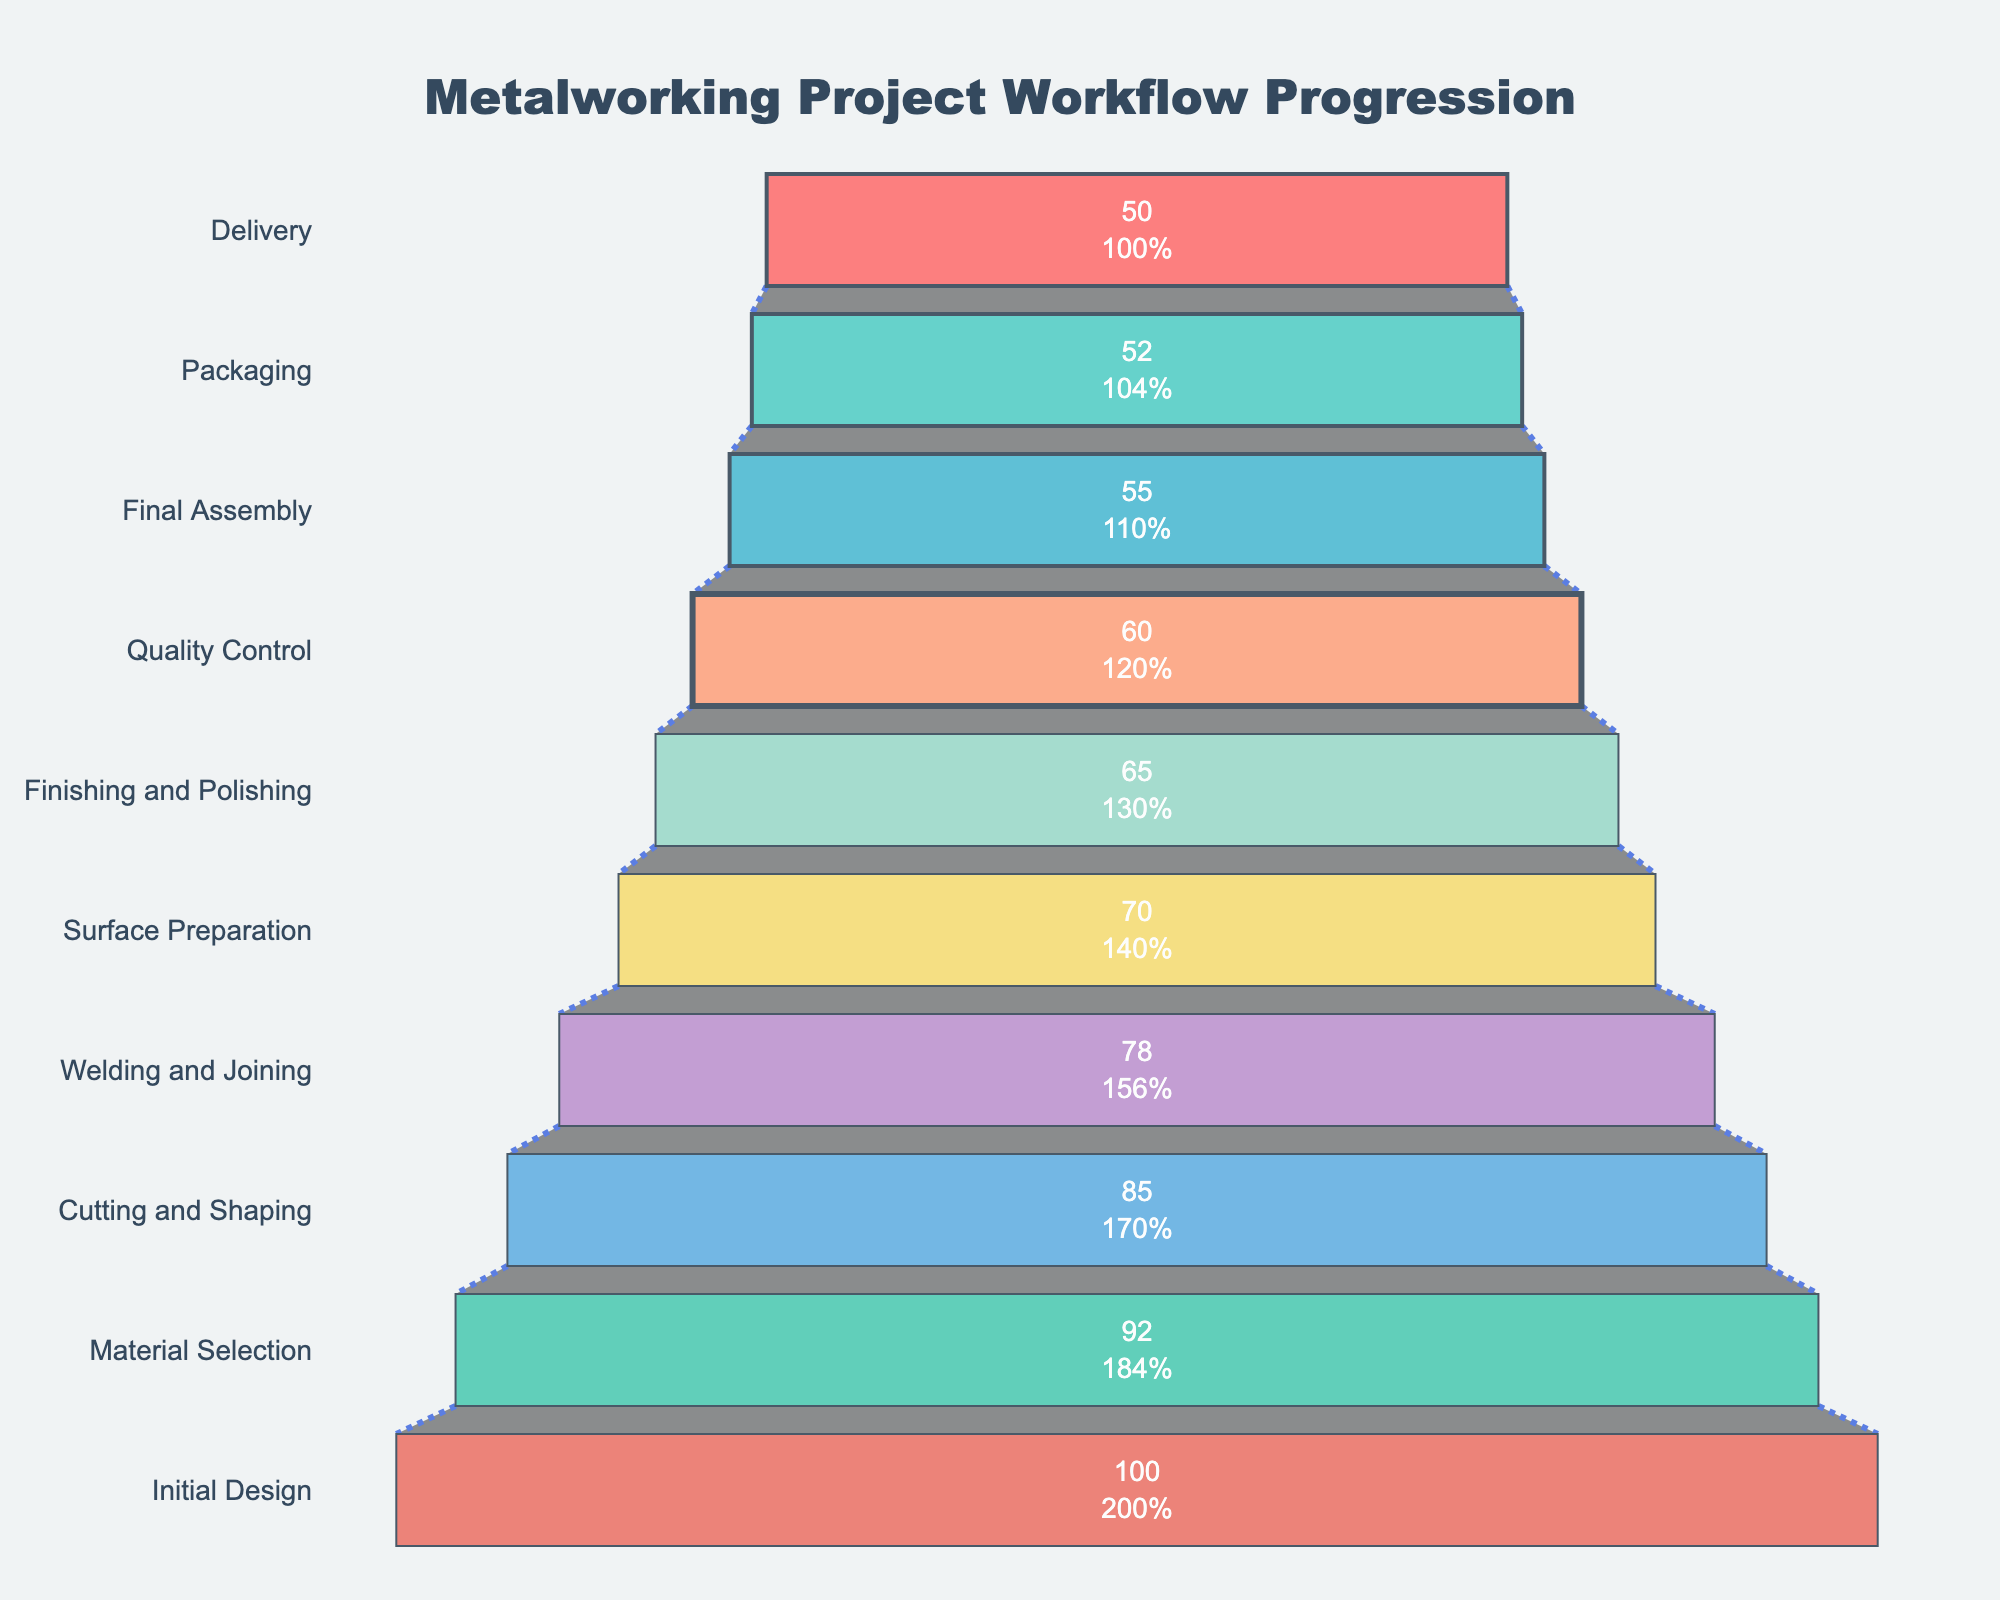what is the title of the funnel chart? The title is typically placed at the top of the chart, which provides an overview of the content. In this case, it reads "Metalworking Project Workflow Progression".
Answer: Metalworking Project Workflow Progression How many stages are listed in the funnel chart? By counting the number of distinct stages listed along the y-axis, you can determine the total number of stages in the workflow.
Answer: 10 Which stage has the highest number of projects? The funnel chart shows the number of projects at each stage along the x-axis. The stage with the highest number is the one at the widest section of the funnel.
Answer: Initial Design How many projects are there in the Final Assembly stage? Locate the Final Assembly stage on the y-axis and identify the associated number of projects along the x-axis, which is marked inside the funnel section.
Answer: 55 What is the difference in the number of projects between the Initial Design and Delivery stages? Subtract the number of projects in the Delivery stage from the number in the Initial Design stage (100 - 50).
Answer: 50 What percentage of projects progressed from Initial Design to Packaging? First, identify the number of projects in Packaging (52) and Initial Design (100). Then, calculate the percentage (52/100 * 100%).
Answer: 52% Which stage shows the most significant drop in the number of projects from the previous stage? Calculate the difference in project numbers between each consecutive stage and identify the highest value. The drop from Cutting and Shaping (85) to Welding and Joining (78) is the greatest.
Answer: Cutting and Shaping to Welding and Joining Can you identify a potential bottleneck in the project workflow? A bottleneck might be indicated by a significant drop in the number of projects between stages. The biggest drop is between Cutting and Shaping and Welding and Joining.
Answer: Welding and Joining What is the average number of projects across all stages? Sum the number of projects for all stages and divide by the total number of stages [(100 + 92 + 85 + 78 + 70 + 65 + 60 + 55 + 52 + 50) / 10].
Answer: 70.7 How many projects are retained from Material Selection to Quality Control? Identify the number of projects at Material Selection (92) and Quality Control (60). Calculate the difference (92 - 60).
Answer: 32 